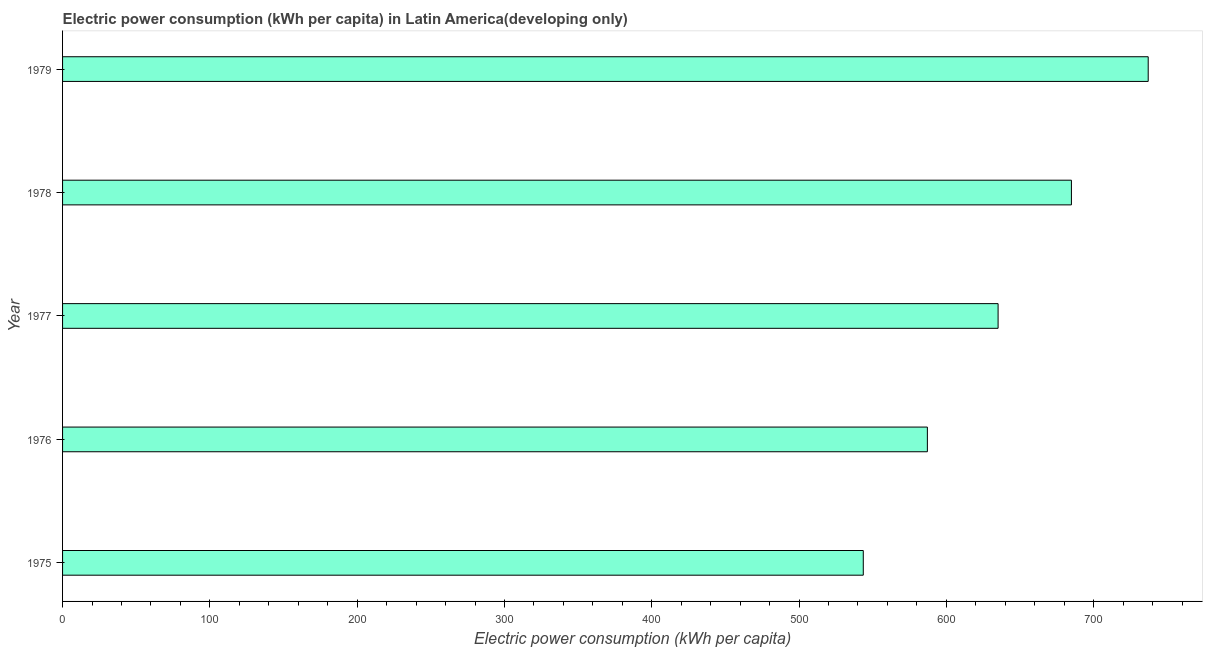What is the title of the graph?
Your answer should be very brief. Electric power consumption (kWh per capita) in Latin America(developing only). What is the label or title of the X-axis?
Your answer should be compact. Electric power consumption (kWh per capita). What is the electric power consumption in 1978?
Give a very brief answer. 684.89. Across all years, what is the maximum electric power consumption?
Provide a succinct answer. 737.03. Across all years, what is the minimum electric power consumption?
Keep it short and to the point. 543.6. In which year was the electric power consumption maximum?
Your response must be concise. 1979. In which year was the electric power consumption minimum?
Keep it short and to the point. 1975. What is the sum of the electric power consumption?
Ensure brevity in your answer.  3187.73. What is the difference between the electric power consumption in 1977 and 1979?
Give a very brief answer. -101.92. What is the average electric power consumption per year?
Provide a short and direct response. 637.55. What is the median electric power consumption?
Offer a very short reply. 635.11. Do a majority of the years between 1977 and 1978 (inclusive) have electric power consumption greater than 400 kWh per capita?
Ensure brevity in your answer.  Yes. What is the ratio of the electric power consumption in 1975 to that in 1976?
Provide a short and direct response. 0.93. Is the electric power consumption in 1976 less than that in 1977?
Provide a short and direct response. Yes. What is the difference between the highest and the second highest electric power consumption?
Offer a terse response. 52.13. Is the sum of the electric power consumption in 1978 and 1979 greater than the maximum electric power consumption across all years?
Your response must be concise. Yes. What is the difference between the highest and the lowest electric power consumption?
Keep it short and to the point. 193.43. In how many years, is the electric power consumption greater than the average electric power consumption taken over all years?
Give a very brief answer. 2. How many bars are there?
Keep it short and to the point. 5. Are all the bars in the graph horizontal?
Offer a very short reply. Yes. How many years are there in the graph?
Keep it short and to the point. 5. What is the Electric power consumption (kWh per capita) in 1975?
Your answer should be compact. 543.6. What is the Electric power consumption (kWh per capita) in 1976?
Keep it short and to the point. 587.1. What is the Electric power consumption (kWh per capita) of 1977?
Provide a succinct answer. 635.11. What is the Electric power consumption (kWh per capita) of 1978?
Your answer should be compact. 684.89. What is the Electric power consumption (kWh per capita) in 1979?
Provide a succinct answer. 737.03. What is the difference between the Electric power consumption (kWh per capita) in 1975 and 1976?
Provide a short and direct response. -43.51. What is the difference between the Electric power consumption (kWh per capita) in 1975 and 1977?
Give a very brief answer. -91.51. What is the difference between the Electric power consumption (kWh per capita) in 1975 and 1978?
Your response must be concise. -141.3. What is the difference between the Electric power consumption (kWh per capita) in 1975 and 1979?
Ensure brevity in your answer.  -193.43. What is the difference between the Electric power consumption (kWh per capita) in 1976 and 1977?
Your answer should be very brief. -48. What is the difference between the Electric power consumption (kWh per capita) in 1976 and 1978?
Provide a short and direct response. -97.79. What is the difference between the Electric power consumption (kWh per capita) in 1976 and 1979?
Your response must be concise. -149.92. What is the difference between the Electric power consumption (kWh per capita) in 1977 and 1978?
Offer a very short reply. -49.78. What is the difference between the Electric power consumption (kWh per capita) in 1977 and 1979?
Keep it short and to the point. -101.92. What is the difference between the Electric power consumption (kWh per capita) in 1978 and 1979?
Give a very brief answer. -52.13. What is the ratio of the Electric power consumption (kWh per capita) in 1975 to that in 1976?
Provide a short and direct response. 0.93. What is the ratio of the Electric power consumption (kWh per capita) in 1975 to that in 1977?
Make the answer very short. 0.86. What is the ratio of the Electric power consumption (kWh per capita) in 1975 to that in 1978?
Ensure brevity in your answer.  0.79. What is the ratio of the Electric power consumption (kWh per capita) in 1975 to that in 1979?
Your response must be concise. 0.74. What is the ratio of the Electric power consumption (kWh per capita) in 1976 to that in 1977?
Ensure brevity in your answer.  0.92. What is the ratio of the Electric power consumption (kWh per capita) in 1976 to that in 1978?
Your answer should be compact. 0.86. What is the ratio of the Electric power consumption (kWh per capita) in 1976 to that in 1979?
Provide a short and direct response. 0.8. What is the ratio of the Electric power consumption (kWh per capita) in 1977 to that in 1978?
Provide a short and direct response. 0.93. What is the ratio of the Electric power consumption (kWh per capita) in 1977 to that in 1979?
Give a very brief answer. 0.86. What is the ratio of the Electric power consumption (kWh per capita) in 1978 to that in 1979?
Your response must be concise. 0.93. 